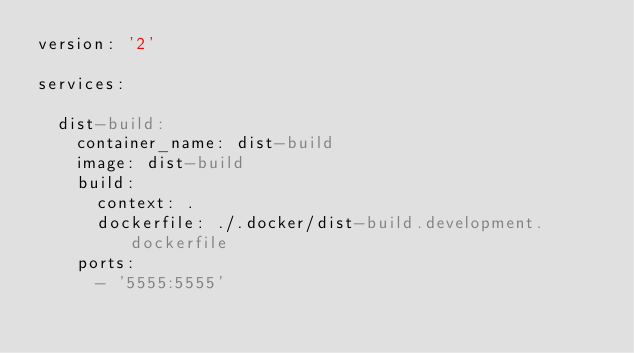Convert code to text. <code><loc_0><loc_0><loc_500><loc_500><_YAML_>version: '2'

services:

  dist-build:
    container_name: dist-build
    image: dist-build
    build:
      context: .
      dockerfile: ./.docker/dist-build.development.dockerfile
    ports:
      - '5555:5555'
</code> 